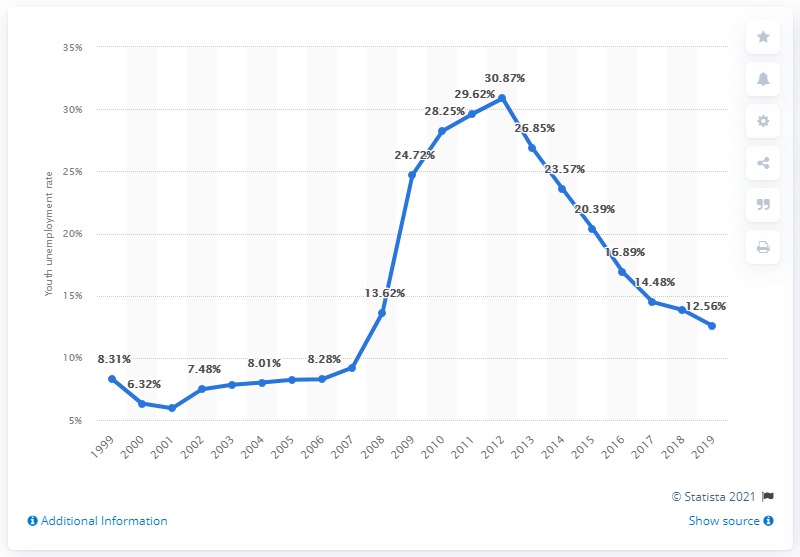Identify some key points in this picture. The youth unemployment rate in Ireland in 2019 was 12.56%. 